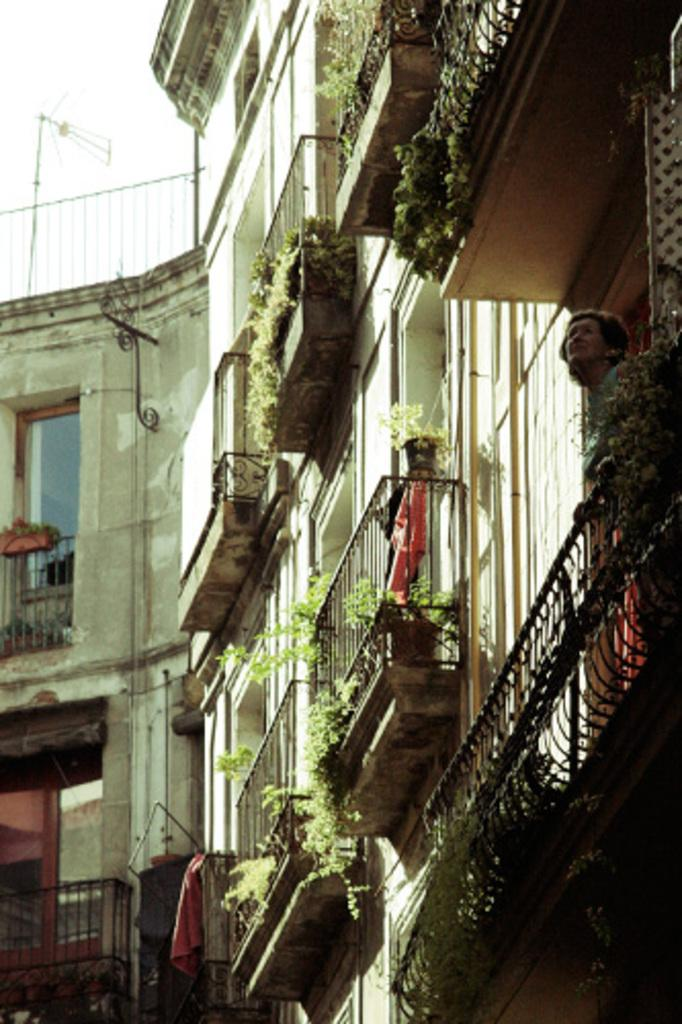What type of structure is visible in the image? There is a building in the image. What feature can be seen on the balconies of the building? The balconies have fences. What is present on the balconies in addition to the fences? There are plants in the balconies. Can you describe the arrangement of the plant on the fence? There is a pot with a plant on the fence. What part of the sky is visible in the image? The sky is visible in the top left corner of the image. What scent can be detected from the calendar in the image? There is no calendar present in the image, so it is not possible to detect any scent from it. 